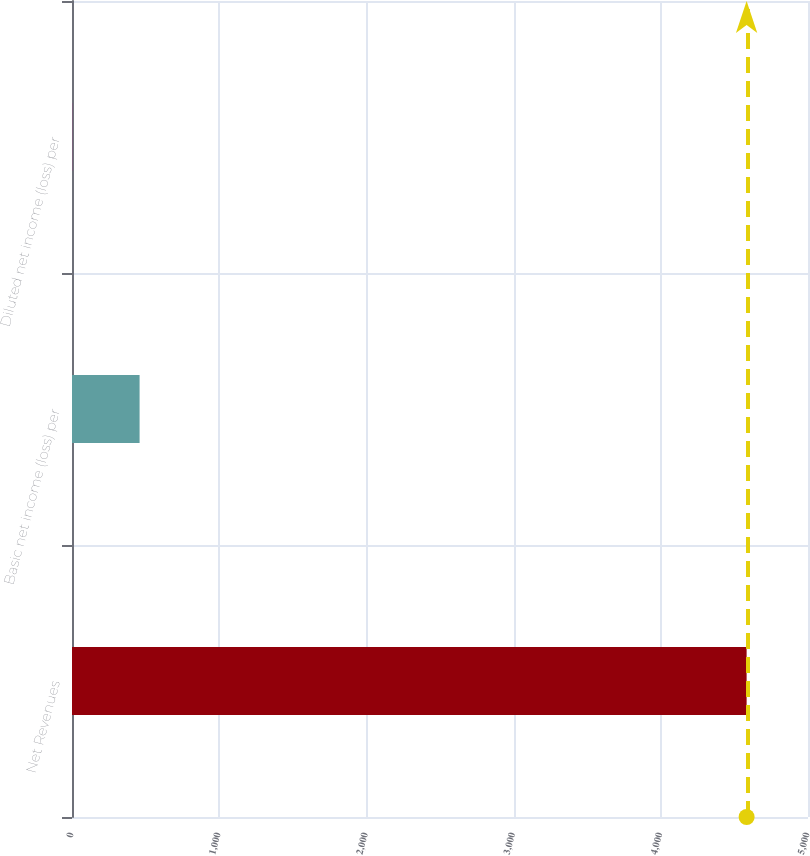Convert chart to OTSL. <chart><loc_0><loc_0><loc_500><loc_500><bar_chart><fcel>Net Revenues<fcel>Basic net income (loss) per<fcel>Diluted net income (loss) per<nl><fcel>4583<fcel>459.16<fcel>0.95<nl></chart> 